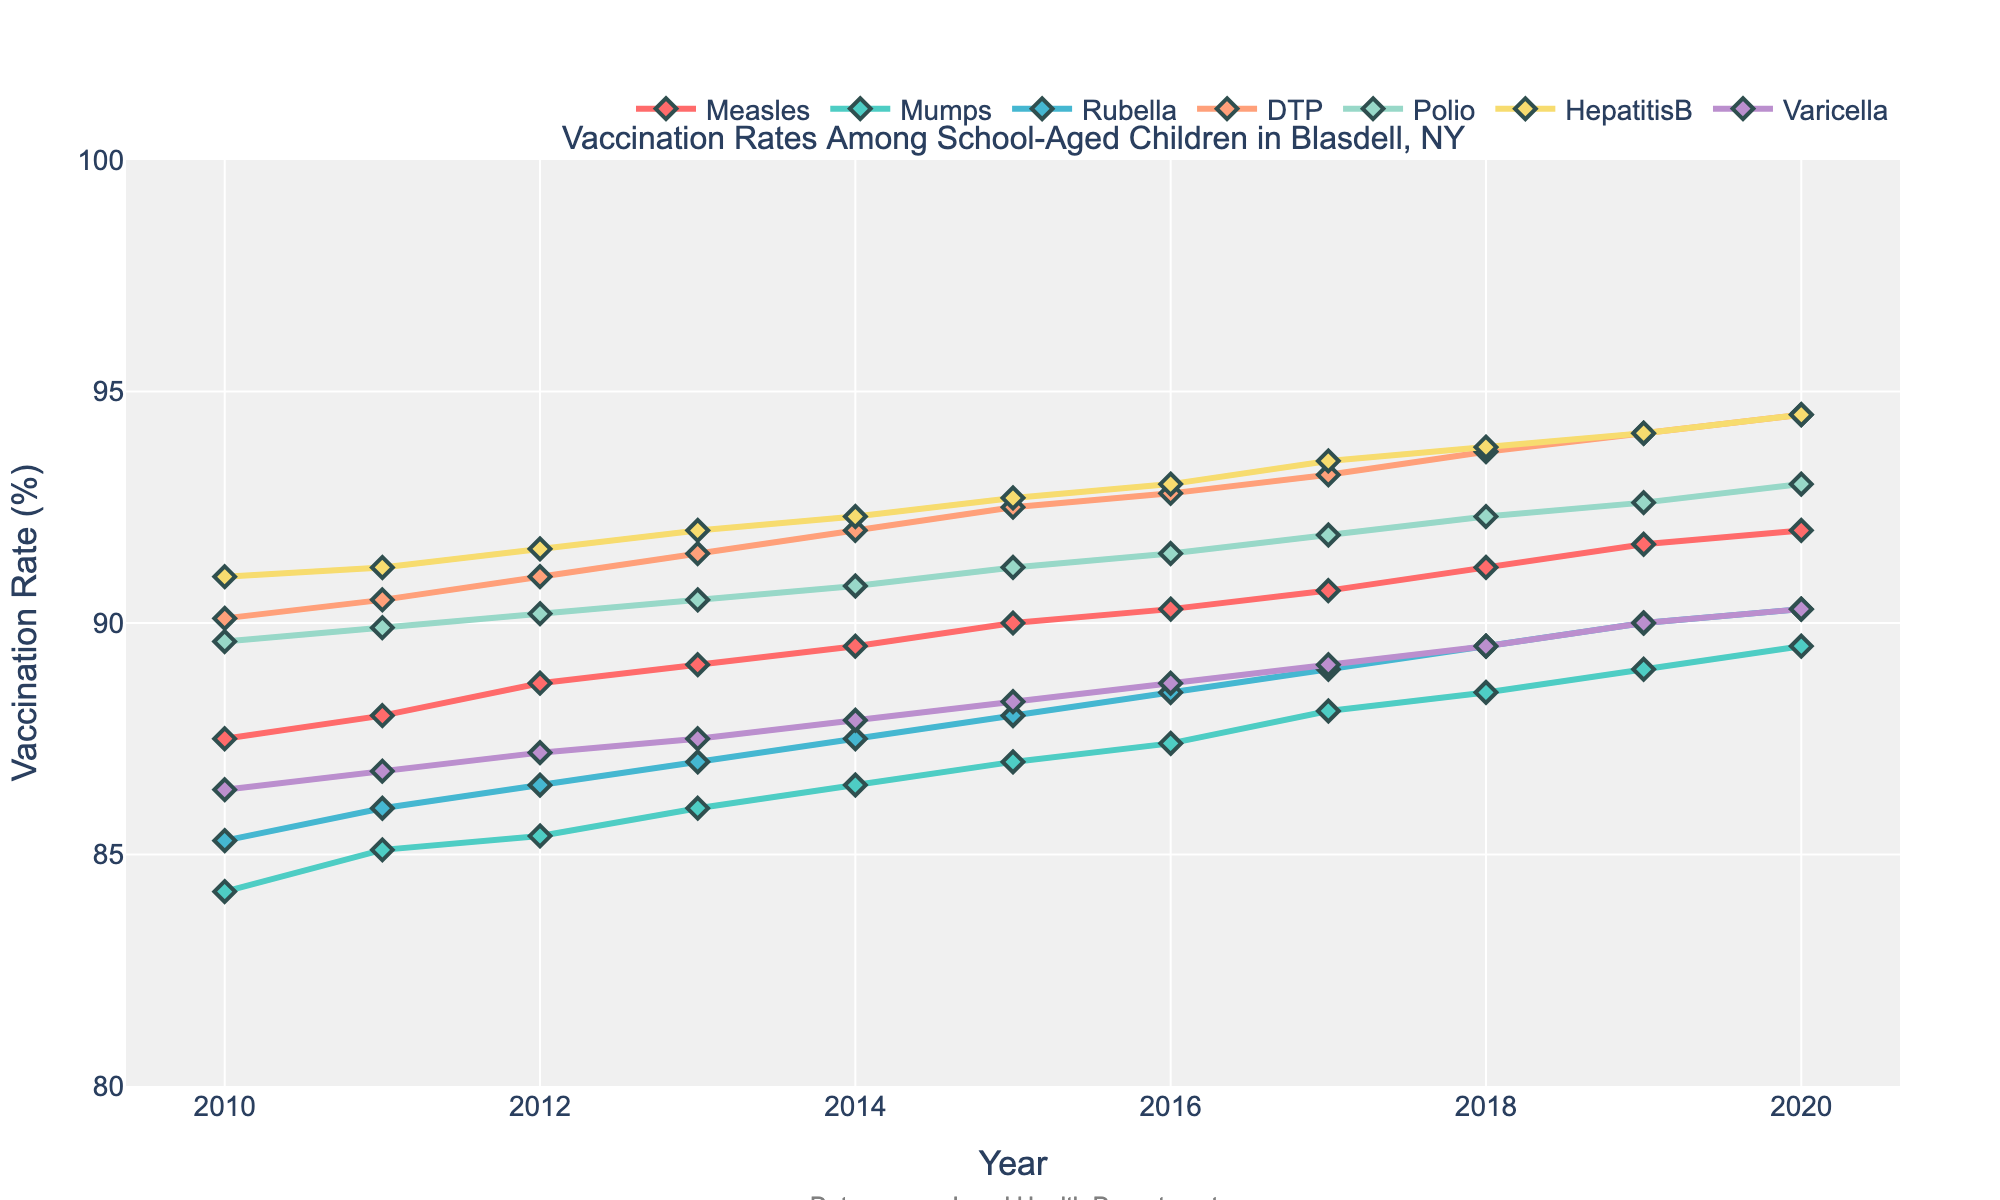What's the title of the figure? The title is located at the top of the plot, typically in larger font to make it stand out. It reads "Vaccination Rates Among School-Aged Children in Blasdell, NY".
Answer: Vaccination Rates Among School-Aged Children in Blasdell, NY What is the range of the y-axis? The y-axis represents the vaccination rates in percentage and is labeled from 80% to 100%, as indicated by the tick marks along the axis.
Answer: 80% to 100% Which vaccine had the highest vaccination rate in 2020? By looking at the data points for the year 2020, we observe that the Hepatitis B vaccination rate is the highest among all the vaccines.
Answer: Hepatitis B What's the general trend of the DTP vaccination rate from 2010 to 2020? Observing the line for DTP, it consistently rises year by year from 90.1% in 2010 to 94.5% in 2020, indicating an increasing trend.
Answer: Increasing trend Which vaccines show a continuous increase in vaccination rates every year from 2010 to 2020? By examining the lines for each vaccine, DTP, Polio, and Hepatitis B show continuous increases without any dips year over year.
Answer: DTP, Polio, Hepatitis B How did the vaccination rate for Measles change from 2010 to 2015? The Measles vaccination rate increased from 87.5% in 2010 to 90.0% in 2015. Calculating the difference, it increased by 90.0% - 87.5% = 2.5%.
Answer: Increased by 2.5% Compare the vaccination rate of Varicella in 2010 and 2019. By how much did it change? The vaccination rate for Varicella in 2010 was 86.4%, and in 2019, it was 90.0%. The change is 90.0% - 86.4% = 3.6%.
Answer: Increased by 3.6% Which vaccine showed the least improvement in vaccination rate over the decade? By comparing the differences from 2010 to 2020 for each vaccine, Mumps increased from 84.2% to 89.5%, resulting in the smallest improvement of 5.3%.
Answer: Mumps Was there any year where the vaccination rate for Rubella did not increase compared to the previous year? The Rubella vaccination rate increases consistently every year from 2010 to 2020, without any dips or stagnations.
Answer: No Is there any vaccine that achieved above 90% rate consistently from 2010 to 2020? Reviewing each line, we find that DTP and Polio have rates consistently above 90% throughout the entire period from 2010 to 2020.
Answer: DTP, Polio 